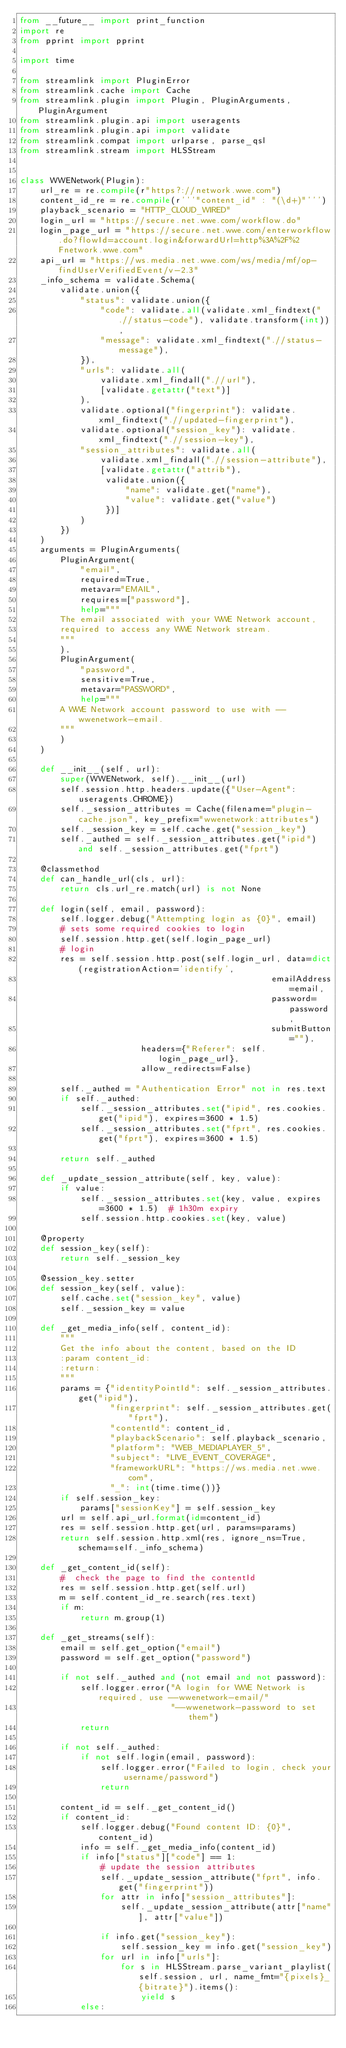Convert code to text. <code><loc_0><loc_0><loc_500><loc_500><_Python_>from __future__ import print_function
import re
from pprint import pprint

import time

from streamlink import PluginError
from streamlink.cache import Cache
from streamlink.plugin import Plugin, PluginArguments, PluginArgument
from streamlink.plugin.api import useragents
from streamlink.plugin.api import validate
from streamlink.compat import urlparse, parse_qsl
from streamlink.stream import HLSStream


class WWENetwork(Plugin):
    url_re = re.compile(r"https?://network.wwe.com")
    content_id_re = re.compile(r'''"content_id" : "(\d+)"''')
    playback_scenario = "HTTP_CLOUD_WIRED"
    login_url = "https://secure.net.wwe.com/workflow.do"
    login_page_url = "https://secure.net.wwe.com/enterworkflow.do?flowId=account.login&forwardUrl=http%3A%2F%2Fnetwork.wwe.com"
    api_url = "https://ws.media.net.wwe.com/ws/media/mf/op-findUserVerifiedEvent/v-2.3"
    _info_schema = validate.Schema(
        validate.union({
            "status": validate.union({
                "code": validate.all(validate.xml_findtext(".//status-code"), validate.transform(int)),
                "message": validate.xml_findtext(".//status-message"),
            }),
            "urls": validate.all(
                validate.xml_findall(".//url"),
                [validate.getattr("text")]
            ),
            validate.optional("fingerprint"): validate.xml_findtext(".//updated-fingerprint"),
            validate.optional("session_key"): validate.xml_findtext(".//session-key"),
            "session_attributes": validate.all(
                validate.xml_findall(".//session-attribute"),
                [validate.getattr("attrib"),
                 validate.union({
                     "name": validate.get("name"),
                     "value": validate.get("value")
                 })]
            )
        })
    )
    arguments = PluginArguments(
        PluginArgument(
            "email",
            required=True,
            metavar="EMAIL",
            requires=["password"],
            help="""
        The email associated with your WWE Network account,
        required to access any WWE Network stream.
        """
        ),
        PluginArgument(
            "password",
            sensitive=True,
            metavar="PASSWORD",
            help="""
        A WWE Network account password to use with --wwenetwork-email.
        """
        )
    )

    def __init__(self, url):
        super(WWENetwork, self).__init__(url)
        self.session.http.headers.update({"User-Agent": useragents.CHROME})
        self._session_attributes = Cache(filename="plugin-cache.json", key_prefix="wwenetwork:attributes")
        self._session_key = self.cache.get("session_key")
        self._authed = self._session_attributes.get("ipid") and self._session_attributes.get("fprt")

    @classmethod
    def can_handle_url(cls, url):
        return cls.url_re.match(url) is not None

    def login(self, email, password):
        self.logger.debug("Attempting login as {0}", email)
        # sets some required cookies to login
        self.session.http.get(self.login_page_url)
        # login
        res = self.session.http.post(self.login_url, data=dict(registrationAction='identify',
                                                  emailAddress=email,
                                                  password=password,
                                                  submitButton=""),
                        headers={"Referer": self.login_page_url},
                        allow_redirects=False)

        self._authed = "Authentication Error" not in res.text
        if self._authed:
            self._session_attributes.set("ipid", res.cookies.get("ipid"), expires=3600 * 1.5)
            self._session_attributes.set("fprt", res.cookies.get("fprt"), expires=3600 * 1.5)

        return self._authed

    def _update_session_attribute(self, key, value):
        if value:
            self._session_attributes.set(key, value, expires=3600 * 1.5)  # 1h30m expiry
            self.session.http.cookies.set(key, value)

    @property
    def session_key(self):
        return self._session_key

    @session_key.setter
    def session_key(self, value):
        self.cache.set("session_key", value)
        self._session_key = value

    def _get_media_info(self, content_id):
        """
        Get the info about the content, based on the ID
        :param content_id:
        :return:
        """
        params = {"identityPointId": self._session_attributes.get("ipid"),
                  "fingerprint": self._session_attributes.get("fprt"),
                  "contentId": content_id,
                  "playbackScenario": self.playback_scenario,
                  "platform": "WEB_MEDIAPLAYER_5",
                  "subject": "LIVE_EVENT_COVERAGE",
                  "frameworkURL": "https://ws.media.net.wwe.com",
                  "_": int(time.time())}
        if self.session_key:
            params["sessionKey"] = self.session_key
        url = self.api_url.format(id=content_id)
        res = self.session.http.get(url, params=params)
        return self.session.http.xml(res, ignore_ns=True, schema=self._info_schema)

    def _get_content_id(self):
        #  check the page to find the contentId
        res = self.session.http.get(self.url)
        m = self.content_id_re.search(res.text)
        if m:
            return m.group(1)

    def _get_streams(self):
        email = self.get_option("email")
        password = self.get_option("password")

        if not self._authed and (not email and not password):
            self.logger.error("A login for WWE Network is required, use --wwenetwork-email/"
                              "--wwenetwork-password to set them")
            return

        if not self._authed:
            if not self.login(email, password):
                self.logger.error("Failed to login, check your username/password")
                return

        content_id = self._get_content_id()
        if content_id:
            self.logger.debug("Found content ID: {0}", content_id)
            info = self._get_media_info(content_id)
            if info["status"]["code"] == 1:
                # update the session attributes
                self._update_session_attribute("fprt", info.get("fingerprint"))
                for attr in info["session_attributes"]:
                    self._update_session_attribute(attr["name"], attr["value"])

                if info.get("session_key"):
                    self.session_key = info.get("session_key")
                for url in info["urls"]:
                    for s in HLSStream.parse_variant_playlist(self.session, url, name_fmt="{pixels}_{bitrate}").items():
                        yield s
            else:</code> 